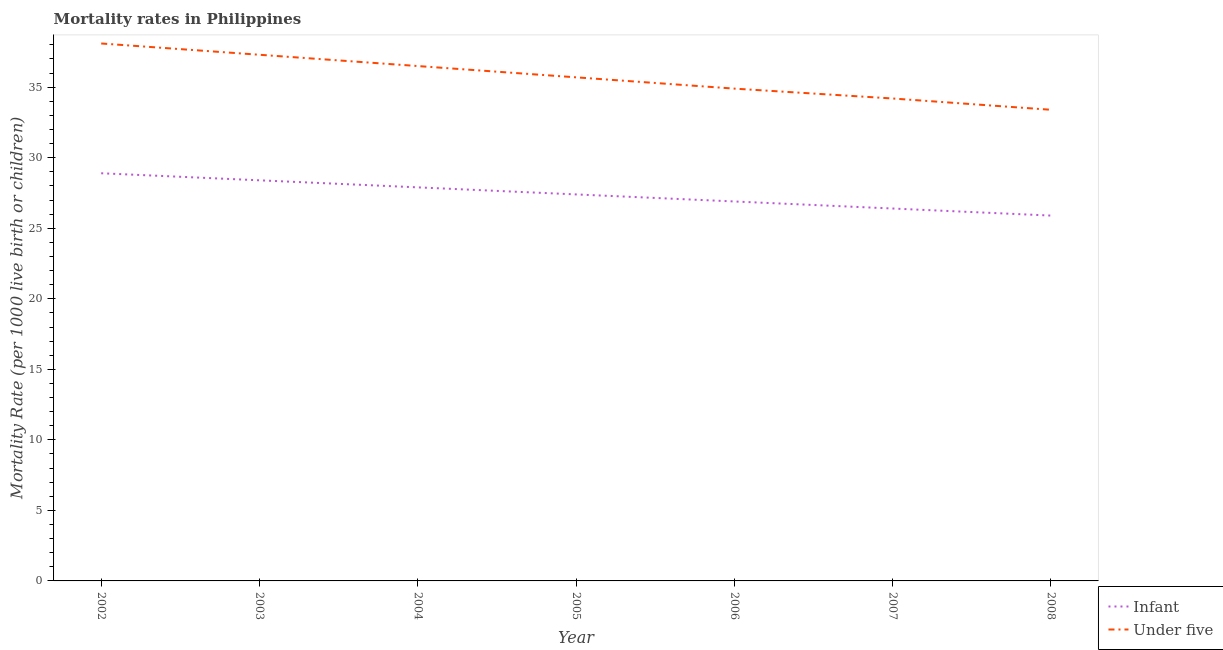Is the number of lines equal to the number of legend labels?
Provide a short and direct response. Yes. What is the infant mortality rate in 2006?
Provide a short and direct response. 26.9. Across all years, what is the maximum under-5 mortality rate?
Make the answer very short. 38.1. Across all years, what is the minimum under-5 mortality rate?
Your answer should be very brief. 33.4. In which year was the infant mortality rate minimum?
Offer a terse response. 2008. What is the total under-5 mortality rate in the graph?
Offer a terse response. 250.1. What is the difference between the under-5 mortality rate in 2007 and the infant mortality rate in 2006?
Your response must be concise. 7.3. What is the average under-5 mortality rate per year?
Keep it short and to the point. 35.73. In the year 2006, what is the difference between the infant mortality rate and under-5 mortality rate?
Provide a short and direct response. -8. What is the ratio of the infant mortality rate in 2003 to that in 2008?
Provide a succinct answer. 1.1. Is the difference between the infant mortality rate in 2004 and 2006 greater than the difference between the under-5 mortality rate in 2004 and 2006?
Keep it short and to the point. No. What is the difference between the highest and the lowest under-5 mortality rate?
Your answer should be compact. 4.7. Is the sum of the under-5 mortality rate in 2005 and 2006 greater than the maximum infant mortality rate across all years?
Your answer should be very brief. Yes. Is the under-5 mortality rate strictly less than the infant mortality rate over the years?
Offer a very short reply. No. How many lines are there?
Offer a terse response. 2. How many years are there in the graph?
Offer a terse response. 7. Does the graph contain any zero values?
Make the answer very short. No. Does the graph contain grids?
Provide a succinct answer. No. Where does the legend appear in the graph?
Provide a succinct answer. Bottom right. How are the legend labels stacked?
Offer a terse response. Vertical. What is the title of the graph?
Your answer should be compact. Mortality rates in Philippines. What is the label or title of the X-axis?
Provide a short and direct response. Year. What is the label or title of the Y-axis?
Your response must be concise. Mortality Rate (per 1000 live birth or children). What is the Mortality Rate (per 1000 live birth or children) of Infant in 2002?
Offer a terse response. 28.9. What is the Mortality Rate (per 1000 live birth or children) of Under five in 2002?
Keep it short and to the point. 38.1. What is the Mortality Rate (per 1000 live birth or children) of Infant in 2003?
Offer a very short reply. 28.4. What is the Mortality Rate (per 1000 live birth or children) in Under five in 2003?
Give a very brief answer. 37.3. What is the Mortality Rate (per 1000 live birth or children) of Infant in 2004?
Your answer should be very brief. 27.9. What is the Mortality Rate (per 1000 live birth or children) of Under five in 2004?
Make the answer very short. 36.5. What is the Mortality Rate (per 1000 live birth or children) of Infant in 2005?
Your answer should be compact. 27.4. What is the Mortality Rate (per 1000 live birth or children) of Under five in 2005?
Offer a very short reply. 35.7. What is the Mortality Rate (per 1000 live birth or children) in Infant in 2006?
Ensure brevity in your answer.  26.9. What is the Mortality Rate (per 1000 live birth or children) in Under five in 2006?
Keep it short and to the point. 34.9. What is the Mortality Rate (per 1000 live birth or children) of Infant in 2007?
Your response must be concise. 26.4. What is the Mortality Rate (per 1000 live birth or children) of Under five in 2007?
Provide a short and direct response. 34.2. What is the Mortality Rate (per 1000 live birth or children) of Infant in 2008?
Your response must be concise. 25.9. What is the Mortality Rate (per 1000 live birth or children) of Under five in 2008?
Your answer should be compact. 33.4. Across all years, what is the maximum Mortality Rate (per 1000 live birth or children) of Infant?
Ensure brevity in your answer.  28.9. Across all years, what is the maximum Mortality Rate (per 1000 live birth or children) of Under five?
Keep it short and to the point. 38.1. Across all years, what is the minimum Mortality Rate (per 1000 live birth or children) of Infant?
Offer a very short reply. 25.9. Across all years, what is the minimum Mortality Rate (per 1000 live birth or children) in Under five?
Provide a short and direct response. 33.4. What is the total Mortality Rate (per 1000 live birth or children) in Infant in the graph?
Your response must be concise. 191.8. What is the total Mortality Rate (per 1000 live birth or children) in Under five in the graph?
Offer a terse response. 250.1. What is the difference between the Mortality Rate (per 1000 live birth or children) in Under five in 2002 and that in 2003?
Provide a succinct answer. 0.8. What is the difference between the Mortality Rate (per 1000 live birth or children) in Infant in 2002 and that in 2004?
Offer a very short reply. 1. What is the difference between the Mortality Rate (per 1000 live birth or children) of Under five in 2002 and that in 2007?
Offer a terse response. 3.9. What is the difference between the Mortality Rate (per 1000 live birth or children) of Under five in 2002 and that in 2008?
Your answer should be compact. 4.7. What is the difference between the Mortality Rate (per 1000 live birth or children) of Infant in 2003 and that in 2004?
Your response must be concise. 0.5. What is the difference between the Mortality Rate (per 1000 live birth or children) in Under five in 2003 and that in 2004?
Make the answer very short. 0.8. What is the difference between the Mortality Rate (per 1000 live birth or children) in Infant in 2003 and that in 2005?
Make the answer very short. 1. What is the difference between the Mortality Rate (per 1000 live birth or children) in Infant in 2003 and that in 2007?
Ensure brevity in your answer.  2. What is the difference between the Mortality Rate (per 1000 live birth or children) of Infant in 2003 and that in 2008?
Offer a very short reply. 2.5. What is the difference between the Mortality Rate (per 1000 live birth or children) of Under five in 2003 and that in 2008?
Keep it short and to the point. 3.9. What is the difference between the Mortality Rate (per 1000 live birth or children) of Under five in 2004 and that in 2005?
Give a very brief answer. 0.8. What is the difference between the Mortality Rate (per 1000 live birth or children) in Infant in 2004 and that in 2006?
Provide a short and direct response. 1. What is the difference between the Mortality Rate (per 1000 live birth or children) in Under five in 2004 and that in 2007?
Your response must be concise. 2.3. What is the difference between the Mortality Rate (per 1000 live birth or children) of Under five in 2004 and that in 2008?
Keep it short and to the point. 3.1. What is the difference between the Mortality Rate (per 1000 live birth or children) in Under five in 2005 and that in 2006?
Give a very brief answer. 0.8. What is the difference between the Mortality Rate (per 1000 live birth or children) of Infant in 2005 and that in 2007?
Make the answer very short. 1. What is the difference between the Mortality Rate (per 1000 live birth or children) of Under five in 2005 and that in 2007?
Give a very brief answer. 1.5. What is the difference between the Mortality Rate (per 1000 live birth or children) in Infant in 2006 and that in 2007?
Ensure brevity in your answer.  0.5. What is the difference between the Mortality Rate (per 1000 live birth or children) of Infant in 2006 and that in 2008?
Keep it short and to the point. 1. What is the difference between the Mortality Rate (per 1000 live birth or children) of Under five in 2006 and that in 2008?
Ensure brevity in your answer.  1.5. What is the difference between the Mortality Rate (per 1000 live birth or children) in Infant in 2002 and the Mortality Rate (per 1000 live birth or children) in Under five in 2004?
Offer a terse response. -7.6. What is the difference between the Mortality Rate (per 1000 live birth or children) in Infant in 2002 and the Mortality Rate (per 1000 live birth or children) in Under five in 2007?
Keep it short and to the point. -5.3. What is the difference between the Mortality Rate (per 1000 live birth or children) in Infant in 2002 and the Mortality Rate (per 1000 live birth or children) in Under five in 2008?
Offer a very short reply. -4.5. What is the difference between the Mortality Rate (per 1000 live birth or children) in Infant in 2003 and the Mortality Rate (per 1000 live birth or children) in Under five in 2005?
Your answer should be compact. -7.3. What is the difference between the Mortality Rate (per 1000 live birth or children) in Infant in 2003 and the Mortality Rate (per 1000 live birth or children) in Under five in 2007?
Offer a terse response. -5.8. What is the difference between the Mortality Rate (per 1000 live birth or children) in Infant in 2004 and the Mortality Rate (per 1000 live birth or children) in Under five in 2005?
Give a very brief answer. -7.8. What is the difference between the Mortality Rate (per 1000 live birth or children) of Infant in 2004 and the Mortality Rate (per 1000 live birth or children) of Under five in 2006?
Provide a short and direct response. -7. What is the difference between the Mortality Rate (per 1000 live birth or children) in Infant in 2005 and the Mortality Rate (per 1000 live birth or children) in Under five in 2006?
Offer a terse response. -7.5. What is the difference between the Mortality Rate (per 1000 live birth or children) of Infant in 2005 and the Mortality Rate (per 1000 live birth or children) of Under five in 2007?
Provide a succinct answer. -6.8. What is the difference between the Mortality Rate (per 1000 live birth or children) in Infant in 2006 and the Mortality Rate (per 1000 live birth or children) in Under five in 2007?
Give a very brief answer. -7.3. What is the difference between the Mortality Rate (per 1000 live birth or children) in Infant in 2006 and the Mortality Rate (per 1000 live birth or children) in Under five in 2008?
Provide a succinct answer. -6.5. What is the average Mortality Rate (per 1000 live birth or children) of Infant per year?
Provide a short and direct response. 27.4. What is the average Mortality Rate (per 1000 live birth or children) of Under five per year?
Make the answer very short. 35.73. In the year 2003, what is the difference between the Mortality Rate (per 1000 live birth or children) of Infant and Mortality Rate (per 1000 live birth or children) of Under five?
Give a very brief answer. -8.9. In the year 2006, what is the difference between the Mortality Rate (per 1000 live birth or children) in Infant and Mortality Rate (per 1000 live birth or children) in Under five?
Make the answer very short. -8. In the year 2007, what is the difference between the Mortality Rate (per 1000 live birth or children) of Infant and Mortality Rate (per 1000 live birth or children) of Under five?
Offer a terse response. -7.8. In the year 2008, what is the difference between the Mortality Rate (per 1000 live birth or children) of Infant and Mortality Rate (per 1000 live birth or children) of Under five?
Provide a short and direct response. -7.5. What is the ratio of the Mortality Rate (per 1000 live birth or children) in Infant in 2002 to that in 2003?
Give a very brief answer. 1.02. What is the ratio of the Mortality Rate (per 1000 live birth or children) of Under five in 2002 to that in 2003?
Give a very brief answer. 1.02. What is the ratio of the Mortality Rate (per 1000 live birth or children) in Infant in 2002 to that in 2004?
Provide a succinct answer. 1.04. What is the ratio of the Mortality Rate (per 1000 live birth or children) in Under five in 2002 to that in 2004?
Ensure brevity in your answer.  1.04. What is the ratio of the Mortality Rate (per 1000 live birth or children) in Infant in 2002 to that in 2005?
Your answer should be very brief. 1.05. What is the ratio of the Mortality Rate (per 1000 live birth or children) in Under five in 2002 to that in 2005?
Your answer should be very brief. 1.07. What is the ratio of the Mortality Rate (per 1000 live birth or children) in Infant in 2002 to that in 2006?
Provide a succinct answer. 1.07. What is the ratio of the Mortality Rate (per 1000 live birth or children) in Under five in 2002 to that in 2006?
Your answer should be compact. 1.09. What is the ratio of the Mortality Rate (per 1000 live birth or children) in Infant in 2002 to that in 2007?
Provide a succinct answer. 1.09. What is the ratio of the Mortality Rate (per 1000 live birth or children) in Under five in 2002 to that in 2007?
Keep it short and to the point. 1.11. What is the ratio of the Mortality Rate (per 1000 live birth or children) in Infant in 2002 to that in 2008?
Your answer should be compact. 1.12. What is the ratio of the Mortality Rate (per 1000 live birth or children) in Under five in 2002 to that in 2008?
Your answer should be compact. 1.14. What is the ratio of the Mortality Rate (per 1000 live birth or children) in Infant in 2003 to that in 2004?
Make the answer very short. 1.02. What is the ratio of the Mortality Rate (per 1000 live birth or children) in Under five in 2003 to that in 2004?
Your response must be concise. 1.02. What is the ratio of the Mortality Rate (per 1000 live birth or children) in Infant in 2003 to that in 2005?
Provide a short and direct response. 1.04. What is the ratio of the Mortality Rate (per 1000 live birth or children) in Under five in 2003 to that in 2005?
Your answer should be very brief. 1.04. What is the ratio of the Mortality Rate (per 1000 live birth or children) in Infant in 2003 to that in 2006?
Give a very brief answer. 1.06. What is the ratio of the Mortality Rate (per 1000 live birth or children) in Under five in 2003 to that in 2006?
Provide a succinct answer. 1.07. What is the ratio of the Mortality Rate (per 1000 live birth or children) of Infant in 2003 to that in 2007?
Provide a succinct answer. 1.08. What is the ratio of the Mortality Rate (per 1000 live birth or children) of Under five in 2003 to that in 2007?
Provide a short and direct response. 1.09. What is the ratio of the Mortality Rate (per 1000 live birth or children) of Infant in 2003 to that in 2008?
Your answer should be compact. 1.1. What is the ratio of the Mortality Rate (per 1000 live birth or children) of Under five in 2003 to that in 2008?
Your response must be concise. 1.12. What is the ratio of the Mortality Rate (per 1000 live birth or children) in Infant in 2004 to that in 2005?
Ensure brevity in your answer.  1.02. What is the ratio of the Mortality Rate (per 1000 live birth or children) of Under five in 2004 to that in 2005?
Keep it short and to the point. 1.02. What is the ratio of the Mortality Rate (per 1000 live birth or children) of Infant in 2004 to that in 2006?
Your answer should be very brief. 1.04. What is the ratio of the Mortality Rate (per 1000 live birth or children) in Under five in 2004 to that in 2006?
Make the answer very short. 1.05. What is the ratio of the Mortality Rate (per 1000 live birth or children) in Infant in 2004 to that in 2007?
Your answer should be very brief. 1.06. What is the ratio of the Mortality Rate (per 1000 live birth or children) of Under five in 2004 to that in 2007?
Your answer should be compact. 1.07. What is the ratio of the Mortality Rate (per 1000 live birth or children) in Infant in 2004 to that in 2008?
Offer a terse response. 1.08. What is the ratio of the Mortality Rate (per 1000 live birth or children) in Under five in 2004 to that in 2008?
Ensure brevity in your answer.  1.09. What is the ratio of the Mortality Rate (per 1000 live birth or children) in Infant in 2005 to that in 2006?
Make the answer very short. 1.02. What is the ratio of the Mortality Rate (per 1000 live birth or children) of Under five in 2005 to that in 2006?
Your answer should be very brief. 1.02. What is the ratio of the Mortality Rate (per 1000 live birth or children) in Infant in 2005 to that in 2007?
Your response must be concise. 1.04. What is the ratio of the Mortality Rate (per 1000 live birth or children) in Under five in 2005 to that in 2007?
Provide a succinct answer. 1.04. What is the ratio of the Mortality Rate (per 1000 live birth or children) of Infant in 2005 to that in 2008?
Ensure brevity in your answer.  1.06. What is the ratio of the Mortality Rate (per 1000 live birth or children) of Under five in 2005 to that in 2008?
Ensure brevity in your answer.  1.07. What is the ratio of the Mortality Rate (per 1000 live birth or children) of Infant in 2006 to that in 2007?
Offer a terse response. 1.02. What is the ratio of the Mortality Rate (per 1000 live birth or children) in Under five in 2006 to that in 2007?
Your response must be concise. 1.02. What is the ratio of the Mortality Rate (per 1000 live birth or children) in Infant in 2006 to that in 2008?
Offer a terse response. 1.04. What is the ratio of the Mortality Rate (per 1000 live birth or children) of Under five in 2006 to that in 2008?
Offer a terse response. 1.04. What is the ratio of the Mortality Rate (per 1000 live birth or children) in Infant in 2007 to that in 2008?
Your answer should be compact. 1.02. What is the ratio of the Mortality Rate (per 1000 live birth or children) of Under five in 2007 to that in 2008?
Make the answer very short. 1.02. 